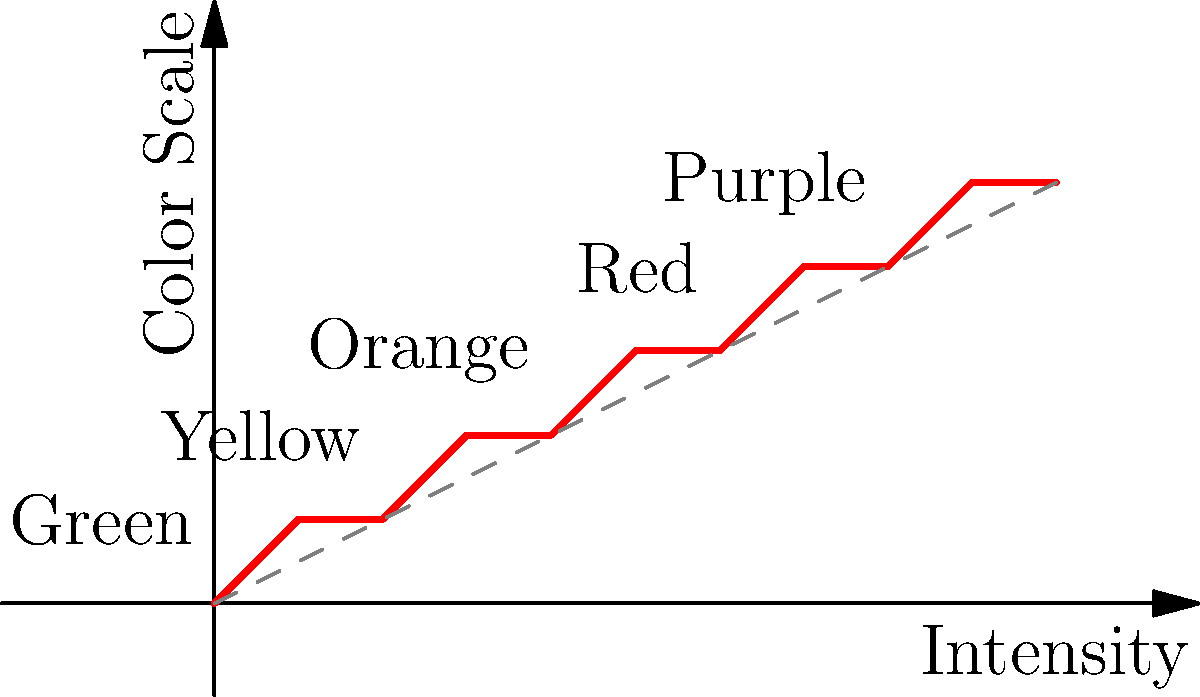Using the color-coded scale in the graph, what color would represent an anxiety intensity level of 7? To determine the color representing an anxiety intensity level of 7, we need to follow these steps:

1. Locate the intensity level 7 on the x-axis.
2. Move vertically from this point until we intersect the color scale line.
3. Identify the corresponding color on the y-axis.

Looking at the graph:
1. We find 7 on the x-axis (Intensity).
2. Moving up from 7, we intersect the color scale line between the "Red" and "Purple" labels.
3. This intersection point corresponds to a y-value of 4 on the Color Scale axis.

The graph shows that:
- Green is at y = 1
- Yellow is at y = 2
- Orange is at y = 3
- Red is at y = 4
- Purple is at y = 5

Since the intersection for intensity 7 is at y = 4, this corresponds to the color Red.
Answer: Red 